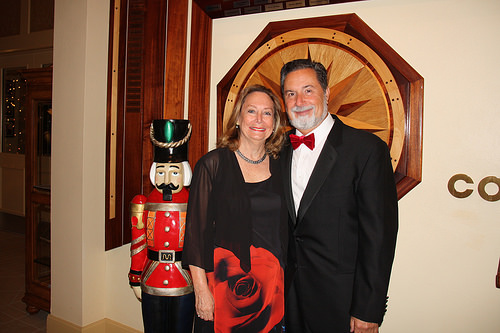<image>
Can you confirm if the man is behind the nutcracker? No. The man is not behind the nutcracker. From this viewpoint, the man appears to be positioned elsewhere in the scene. Is there a nutcracker in front of the man? No. The nutcracker is not in front of the man. The spatial positioning shows a different relationship between these objects. 